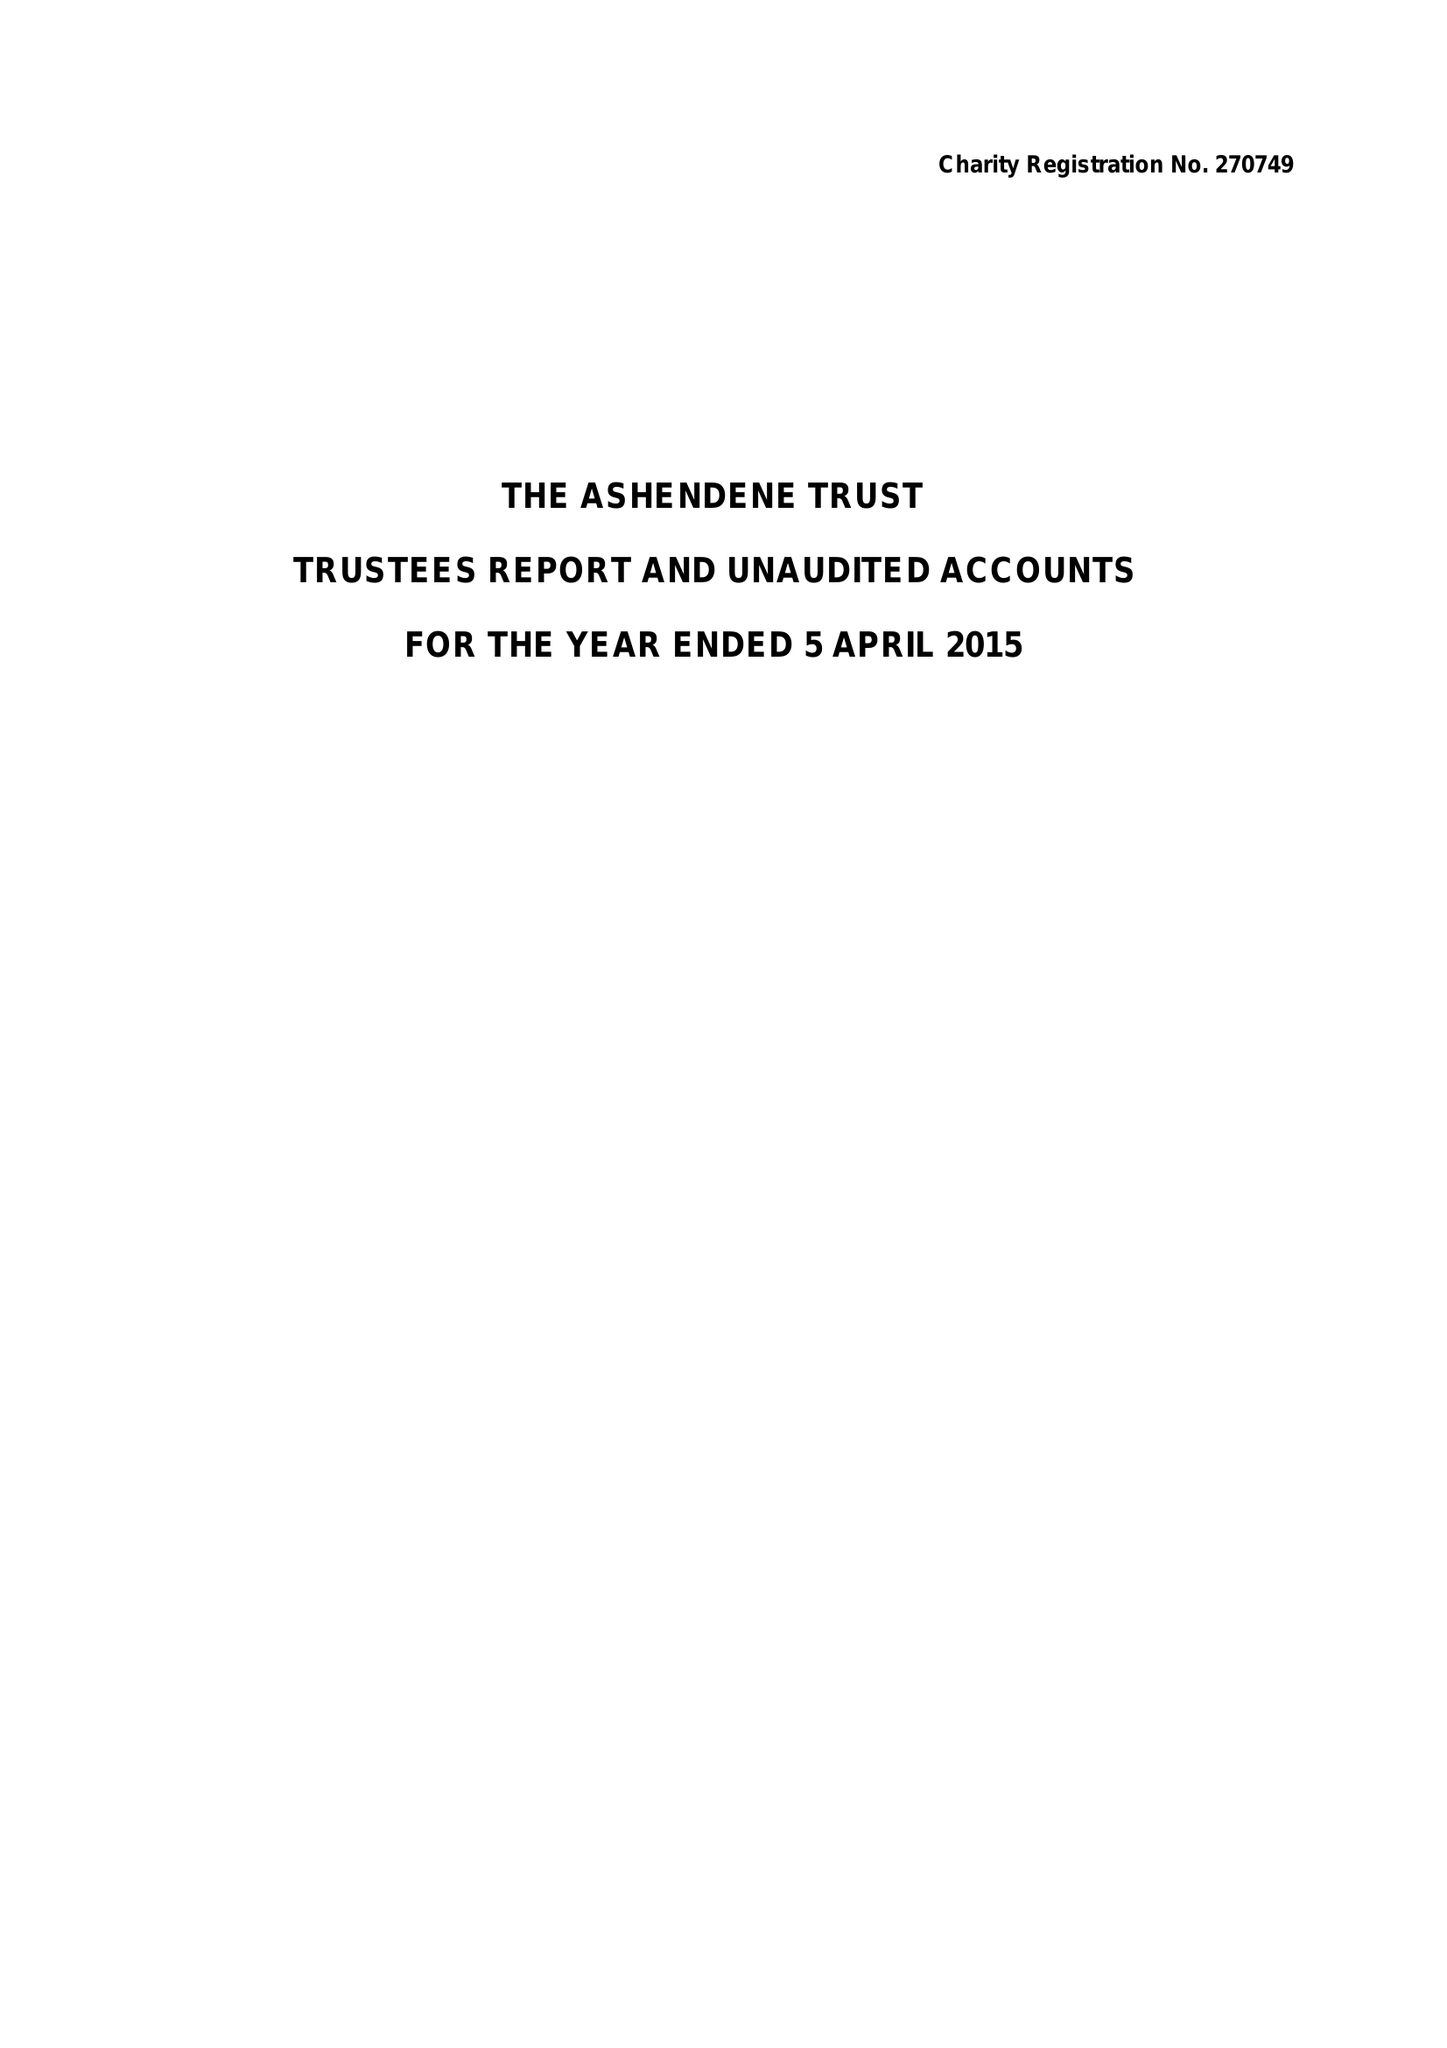What is the value for the report_date?
Answer the question using a single word or phrase. 2015-04-05 